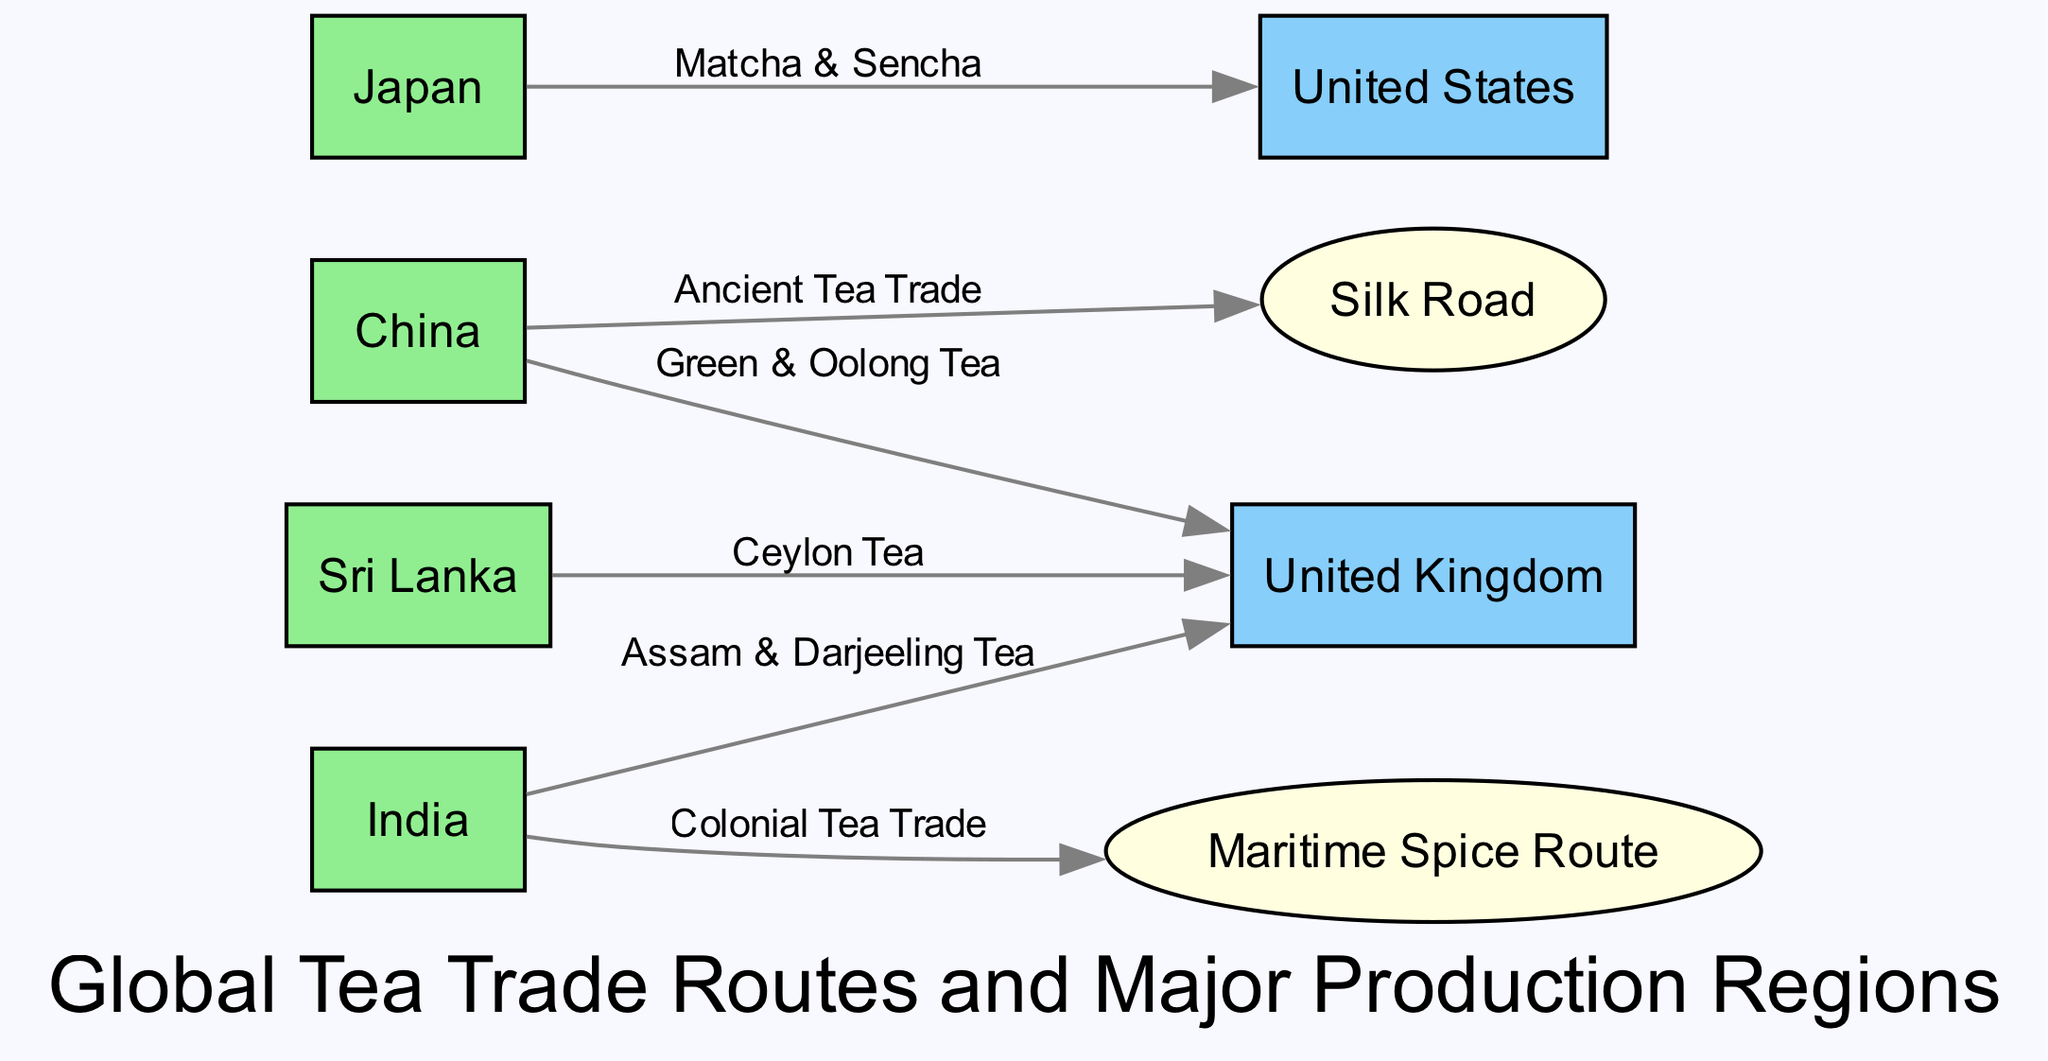What are the major production regions for tea in the diagram? The diagram lists four production regions: China, India, Sri Lanka, and Japan.
Answer: China, India, Sri Lanka, Japan Which historical route is associated with ancient tea trade? The edge connecting China to the Silk Road is labeled "Ancient Tea Trade," indicating this route's historical significance in tea trade.
Answer: Silk Road How many import hubs are represented in the diagram? There are two distinct import hubs shown: the United Kingdom and the United States.
Answer: 2 What type of tea is associated with India and the United Kingdom? The diagram specifies that Assam and Darjeeling tea are exported from India to the United Kingdom, as shown on the edge connecting these nodes.
Answer: Assam & Darjeeling Tea Which type of tea is linked to Japan in the diagram? According to the edge from Japan to the United States, the types of tea being exported are Matcha and Sencha.
Answer: Matcha & Sencha Which production region connects to the Maritime Spice Route? The diagram shows a connection from India to the Maritime Spice Route, labeled as "Colonial Tea Trade," indicating this route's significance for tea from India.
Answer: India What is the relationship between China and the United Kingdom regarding tea types? The edge from China to the United Kingdom indicates that Green and Oolong teas are transported along this trade route.
Answer: Green & Oolong Tea Identify one historical trade route in the diagram. The diagram presents two historical routes, one of which is the Silk Road, as indicated by its categorization and connection to China.
Answer: Silk Road Which production region exports Ceylon tea and to where? The edge from Sri Lanka to the United Kingdom demonstrates that Ceylon tea is exported to this import hub.
Answer: United Kingdom 